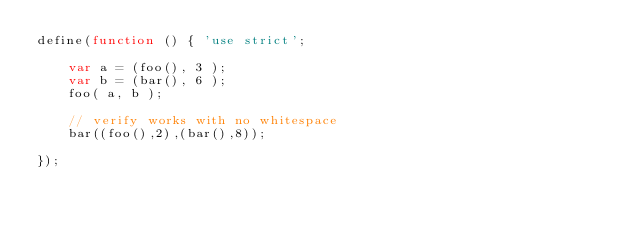Convert code to text. <code><loc_0><loc_0><loc_500><loc_500><_JavaScript_>define(function () { 'use strict';

	var a = (foo(), 3 );
	var b = (bar(), 6 );
	foo( a, b );

	// verify works with no whitespace
	bar((foo(),2),(bar(),8));

});
</code> 